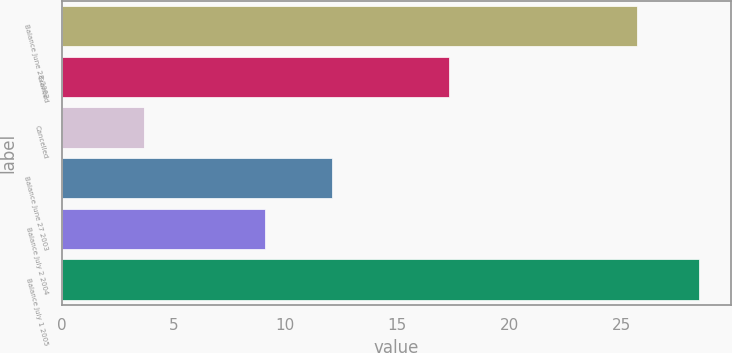<chart> <loc_0><loc_0><loc_500><loc_500><bar_chart><fcel>Balance June 28 2002<fcel>Granted<fcel>Cancelled<fcel>Balance June 27 2003<fcel>Balance July 2 2004<fcel>Balance July 1 2005<nl><fcel>25.7<fcel>17.3<fcel>3.7<fcel>12.1<fcel>9.1<fcel>28.5<nl></chart> 